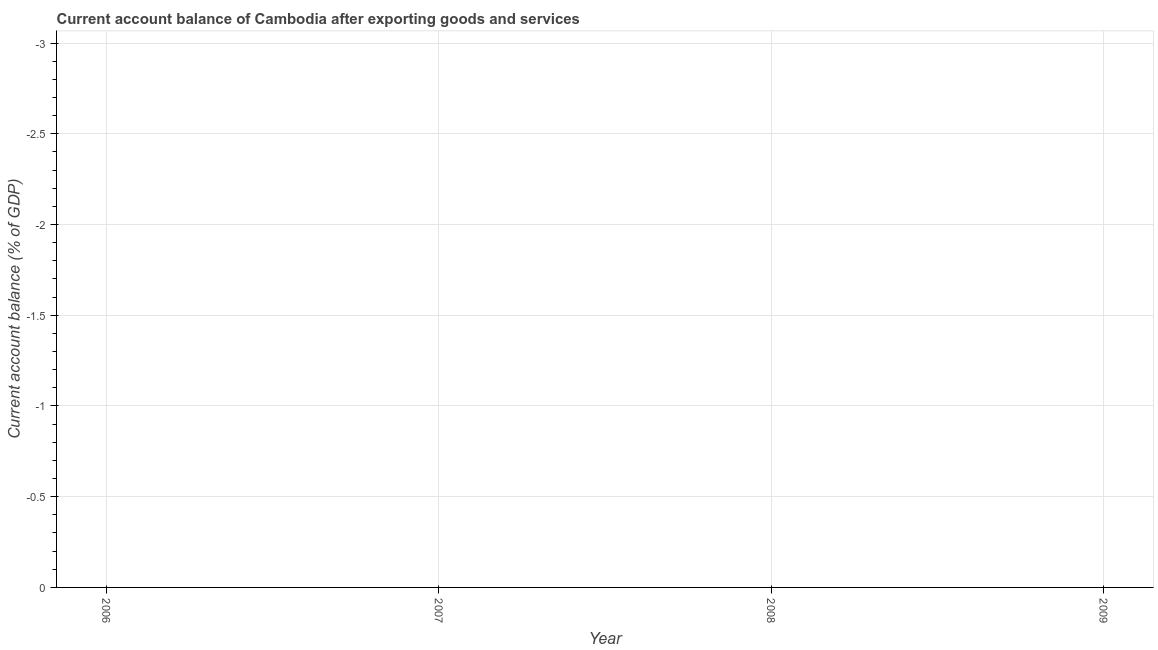What is the sum of the current account balance?
Your response must be concise. 0. What is the median current account balance?
Keep it short and to the point. 0. In how many years, is the current account balance greater than -2.6 %?
Give a very brief answer. 0. How many lines are there?
Your answer should be compact. 0. Does the graph contain any zero values?
Provide a short and direct response. Yes. Does the graph contain grids?
Make the answer very short. Yes. What is the title of the graph?
Make the answer very short. Current account balance of Cambodia after exporting goods and services. What is the label or title of the X-axis?
Offer a very short reply. Year. What is the label or title of the Y-axis?
Your response must be concise. Current account balance (% of GDP). What is the Current account balance (% of GDP) in 2006?
Keep it short and to the point. 0. What is the Current account balance (% of GDP) of 2009?
Make the answer very short. 0. 